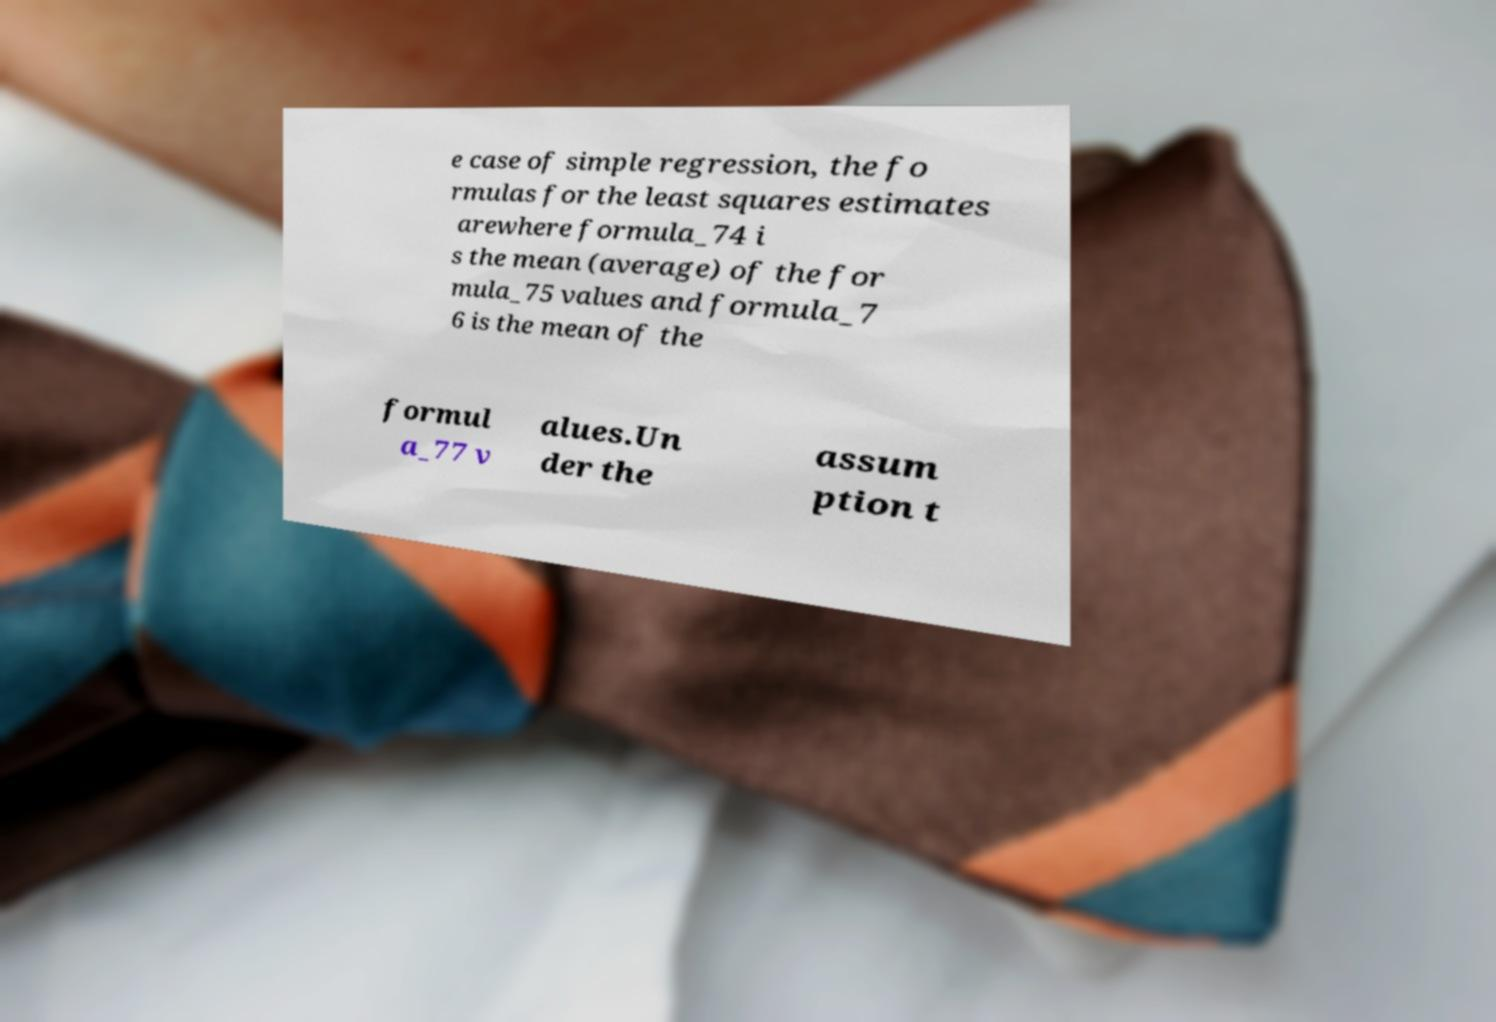There's text embedded in this image that I need extracted. Can you transcribe it verbatim? e case of simple regression, the fo rmulas for the least squares estimates arewhere formula_74 i s the mean (average) of the for mula_75 values and formula_7 6 is the mean of the formul a_77 v alues.Un der the assum ption t 